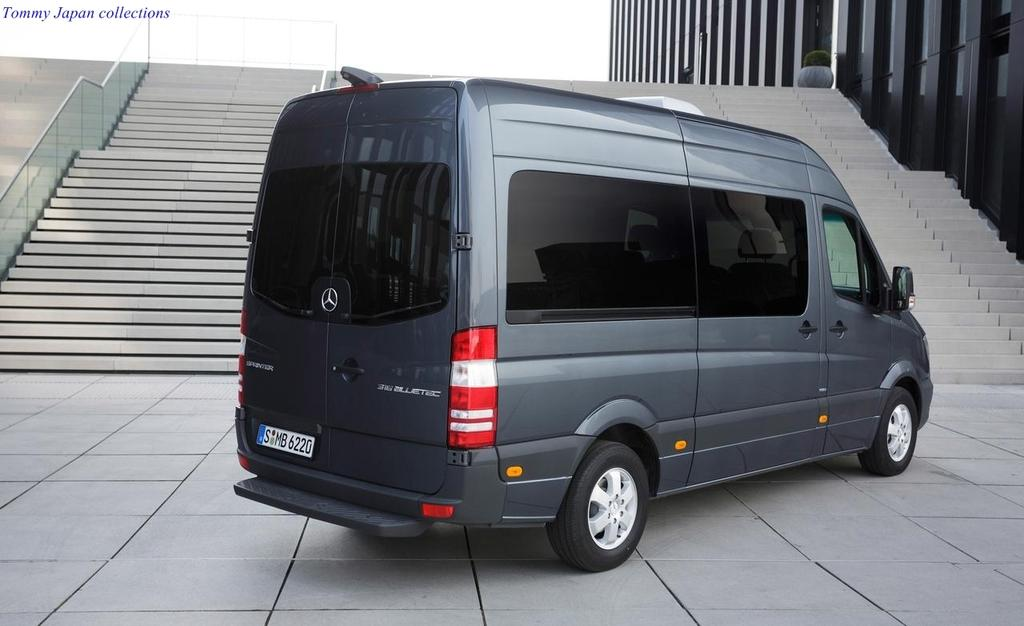<image>
Summarize the visual content of the image. A grey mercedes van with tag reading S MB 6220. 